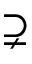Convert formula to latex. <formula><loc_0><loc_0><loc_500><loc_500>\supsetneq</formula> 